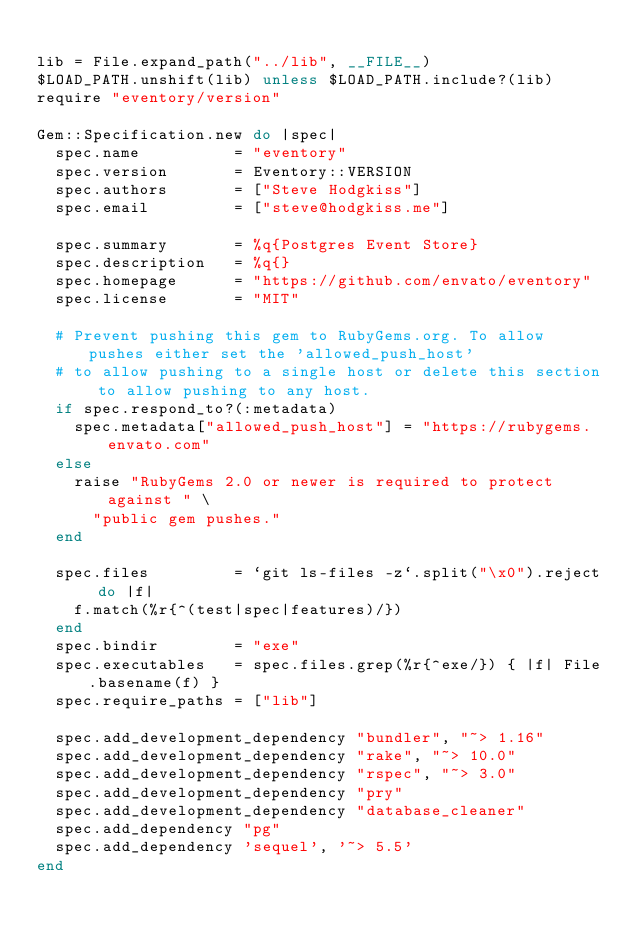<code> <loc_0><loc_0><loc_500><loc_500><_Ruby_>
lib = File.expand_path("../lib", __FILE__)
$LOAD_PATH.unshift(lib) unless $LOAD_PATH.include?(lib)
require "eventory/version"

Gem::Specification.new do |spec|
  spec.name          = "eventory"
  spec.version       = Eventory::VERSION
  spec.authors       = ["Steve Hodgkiss"]
  spec.email         = ["steve@hodgkiss.me"]

  spec.summary       = %q{Postgres Event Store}
  spec.description   = %q{}
  spec.homepage      = "https://github.com/envato/eventory"
  spec.license       = "MIT"

  # Prevent pushing this gem to RubyGems.org. To allow pushes either set the 'allowed_push_host'
  # to allow pushing to a single host or delete this section to allow pushing to any host.
  if spec.respond_to?(:metadata)
    spec.metadata["allowed_push_host"] = "https://rubygems.envato.com"
  else
    raise "RubyGems 2.0 or newer is required to protect against " \
      "public gem pushes."
  end

  spec.files         = `git ls-files -z`.split("\x0").reject do |f|
    f.match(%r{^(test|spec|features)/})
  end
  spec.bindir        = "exe"
  spec.executables   = spec.files.grep(%r{^exe/}) { |f| File.basename(f) }
  spec.require_paths = ["lib"]

  spec.add_development_dependency "bundler", "~> 1.16"
  spec.add_development_dependency "rake", "~> 10.0"
  spec.add_development_dependency "rspec", "~> 3.0"
  spec.add_development_dependency "pry"
  spec.add_development_dependency "database_cleaner"
  spec.add_dependency "pg"
  spec.add_dependency 'sequel', '~> 5.5'
end
</code> 